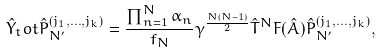Convert formula to latex. <formula><loc_0><loc_0><loc_500><loc_500>\hat { Y } _ { t } o t \hat { P } _ { N ^ { \prime } } ^ { ( j _ { 1 } , \dots , j _ { k } ) } = \frac { \prod _ { n = 1 } ^ { N } \alpha _ { n } } { f _ { N } } \gamma ^ { \frac { N ( N - 1 ) } { 2 } } \hat { T } ^ { N } F ( \hat { A } ) \hat { P } _ { N ^ { \prime } } ^ { ( j _ { 1 } , \dots , j _ { k } ) } ,</formula> 